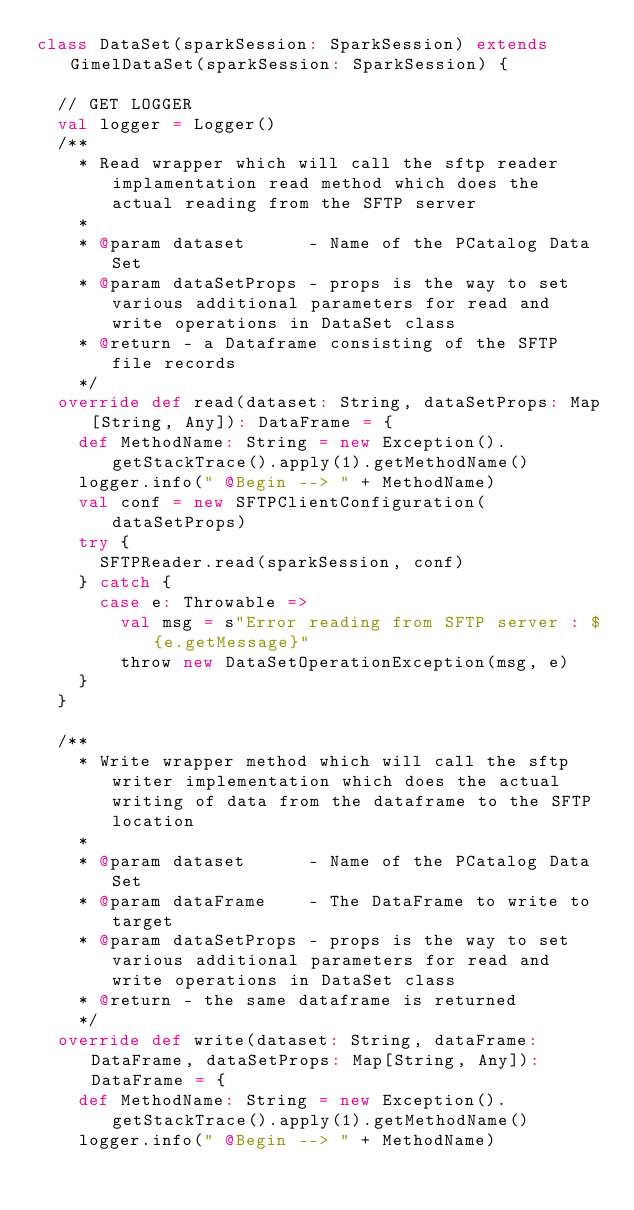Convert code to text. <code><loc_0><loc_0><loc_500><loc_500><_Scala_>class DataSet(sparkSession: SparkSession) extends GimelDataSet(sparkSession: SparkSession) {

  // GET LOGGER
  val logger = Logger()
  /**
    * Read wrapper which will call the sftp reader implamentation read method which does the actual reading from the SFTP server
    *
    * @param dataset      - Name of the PCatalog Data Set
    * @param dataSetProps - props is the way to set various additional parameters for read and write operations in DataSet class
    * @return - a Dataframe consisting of the SFTP file records
    */
  override def read(dataset: String, dataSetProps: Map[String, Any]): DataFrame = {
    def MethodName: String = new Exception().getStackTrace().apply(1).getMethodName()
    logger.info(" @Begin --> " + MethodName)
    val conf = new SFTPClientConfiguration(dataSetProps)
    try {
      SFTPReader.read(sparkSession, conf)
    } catch {
      case e: Throwable =>
        val msg = s"Error reading from SFTP server : ${e.getMessage}"
        throw new DataSetOperationException(msg, e)
    }
  }

  /**
    * Write wrapper method which will call the sftp writer implementation which does the actual writing of data from the dataframe to the SFTP location
    *
    * @param dataset      - Name of the PCatalog Data Set
    * @param dataFrame    - The DataFrame to write to target
    * @param dataSetProps - props is the way to set various additional parameters for read and write operations in DataSet class
    * @return - the same dataframe is returned
    */
  override def write(dataset: String, dataFrame: DataFrame, dataSetProps: Map[String, Any]): DataFrame = {
    def MethodName: String = new Exception().getStackTrace().apply(1).getMethodName()
    logger.info(" @Begin --> " + MethodName)</code> 